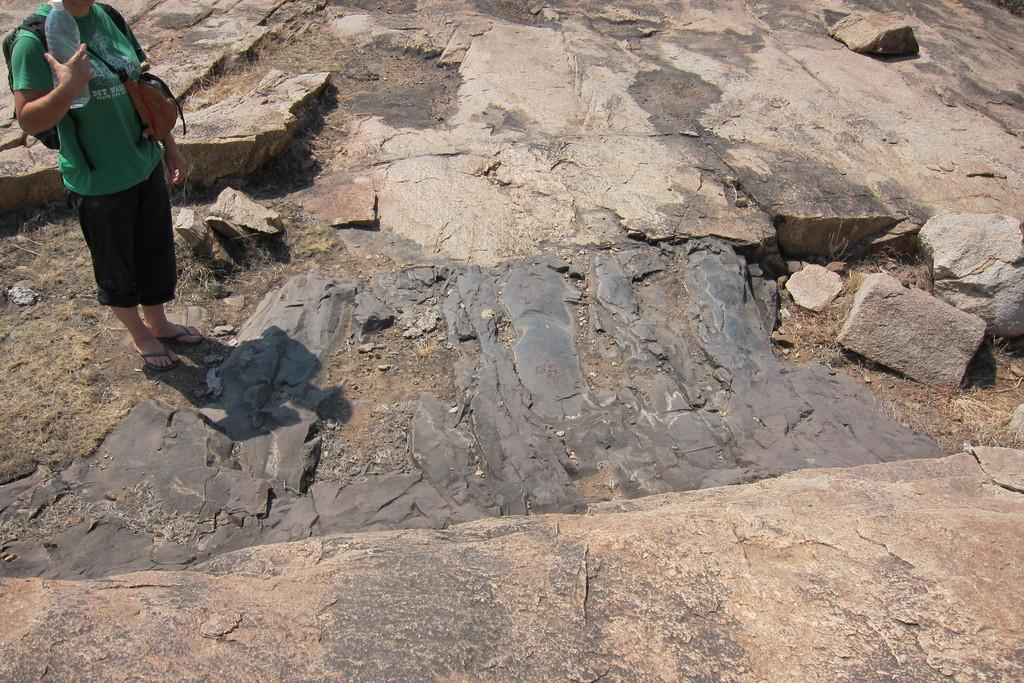What is the person on the left side of the image doing? The person is standing on the left side of the image. What is the person wearing? The person is wearing a dress. What object is the person holding? The person is holding a bottle. What else is associated with the person in the image? There are bags associated with the person. What can be seen in the background of the image? The background of the image includes a rock surface. What type of bells can be heard ringing in the image? There are no bells present in the image, and therefore no sound can be heard. 